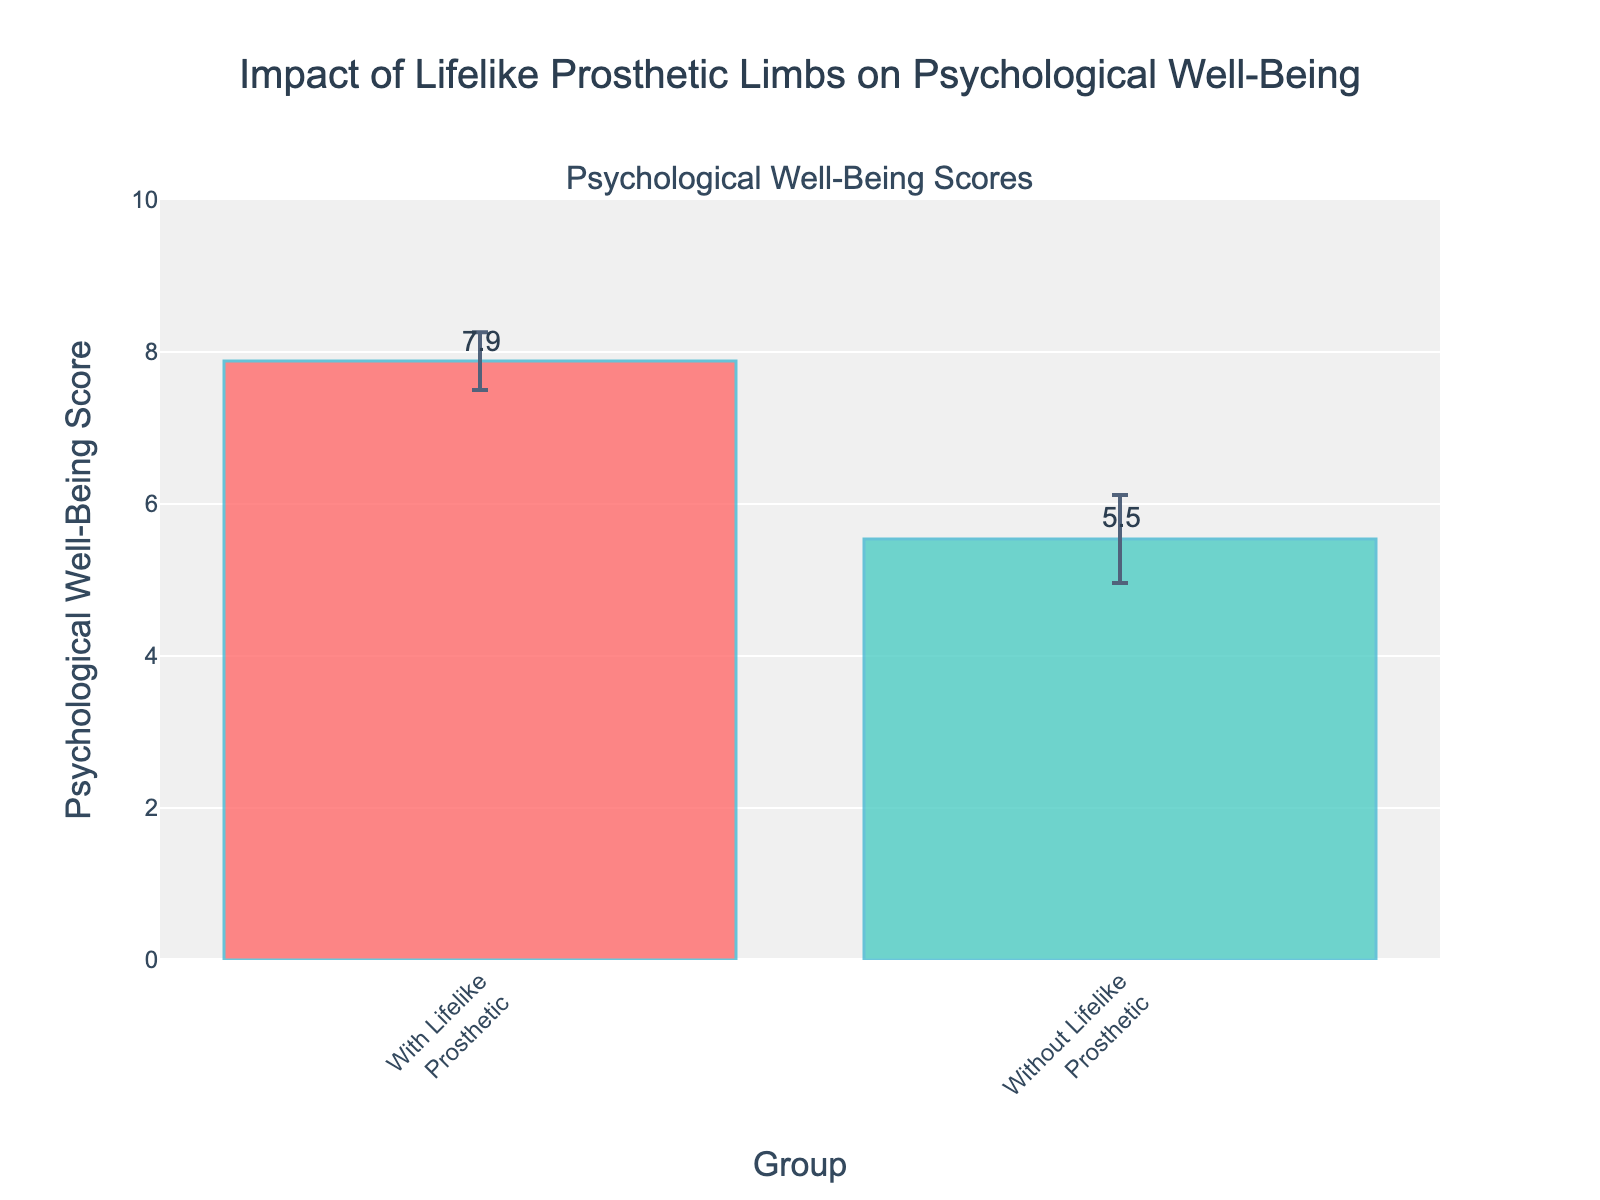What's the title of the figure? The title is prominently displayed at the top of the figure for context.
Answer: Impact of Lifelike Prosthetic Limbs on Psychological Well-Being What are the two groups compared in the figure? The x-axis labels indicate the two groups being compared.
Answer: With Lifelike Prosthetic and Without Lifelike Prosthetic Which group has a higher average Psychological Well-Being Score? By looking at the bar heights, the group with the higher bar has the higher average score.
Answer: With Lifelike Prosthetic What is the average Psychological Well-Being Score for the "Without Lifelike Prosthetic" group? The numeric label on top of the bar for the "Without Lifelike Prosthetic" group gives this information.
Answer: 5.54 How much higher is the Psychological Well-Being Score for the "With Lifelike Prosthetic" group compared to the "Without Lifelike Prosthetic" group? Subtract the score of the "Without Lifelike Prosthetic" group from the score of the "With Lifelike Prosthetic" group. (7.88 - 5.54)
Answer: 2.34 What does the length of the error bars represent? The error bars indicate the standard deviation of the psychological well-being scores, representing data variability.
Answer: Standard deviation Which group has smaller variability in their psychological well-being scores? The group with the shorter error bars has smaller variability.
Answer: With Lifelike Prosthetic By how much does the standard deviation differ between the groups? Subtract the standard deviation of the "With Lifelike Prosthetic" group from that of the "Without Lifelike Prosthetic" group. (0.46 - 0.58)
Answer: -0.12 